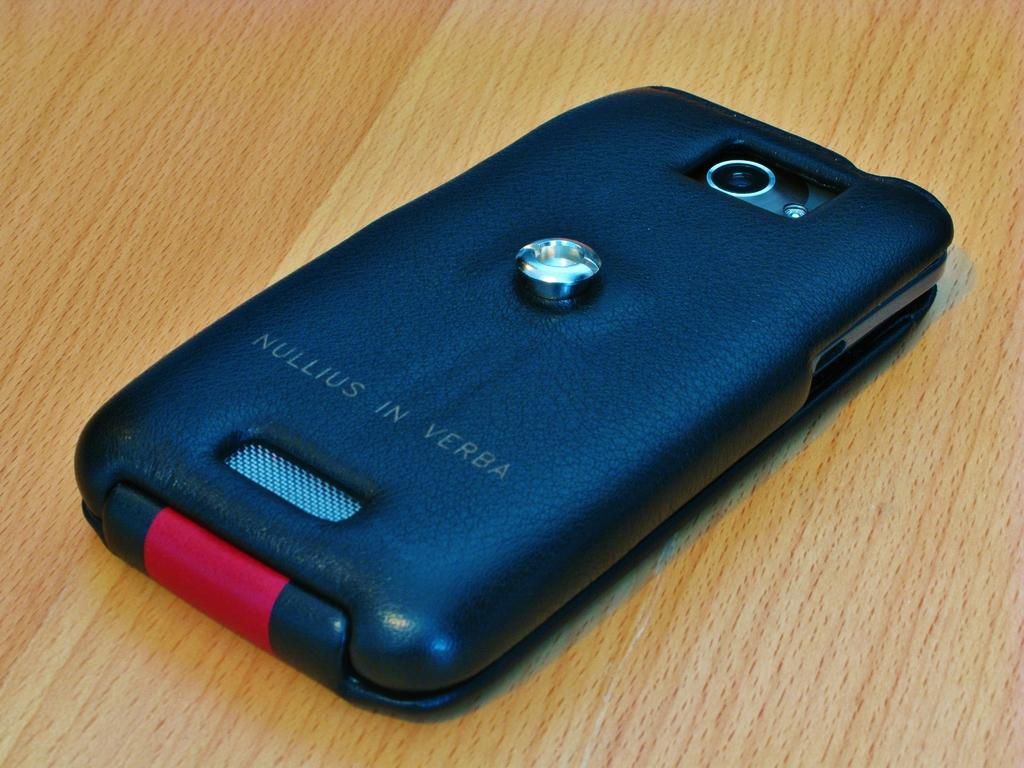Provide a one-sentence caption for the provided image. Nullius in Verba case on a phone on the table. 